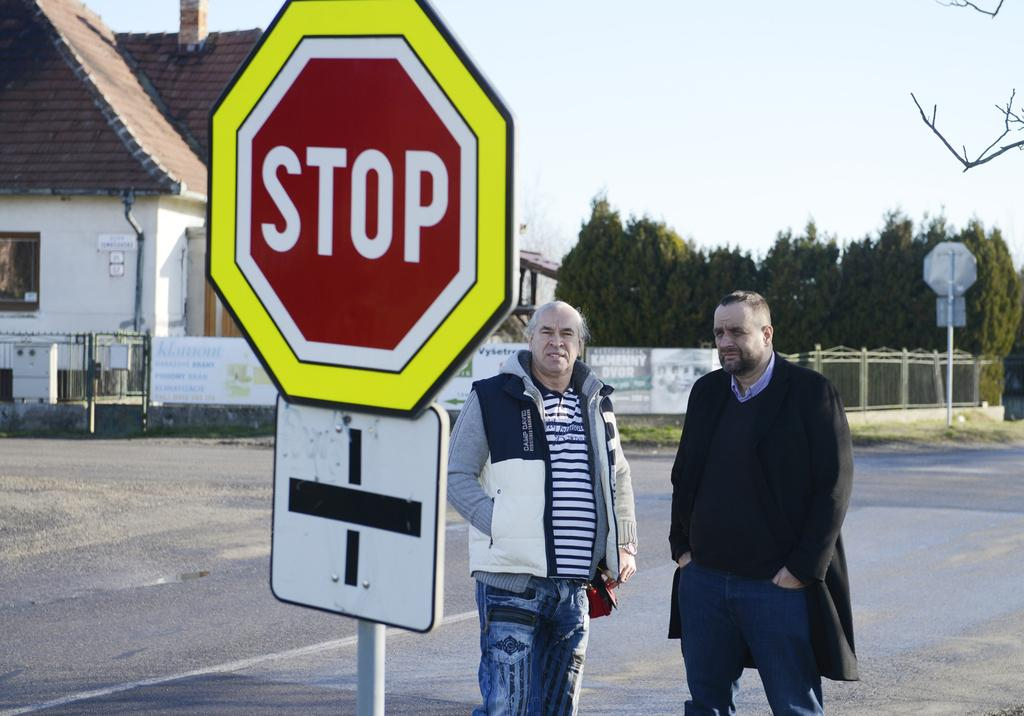<image>
Share a concise interpretation of the image provided. Two men standing in front of a sign which says STOP. 